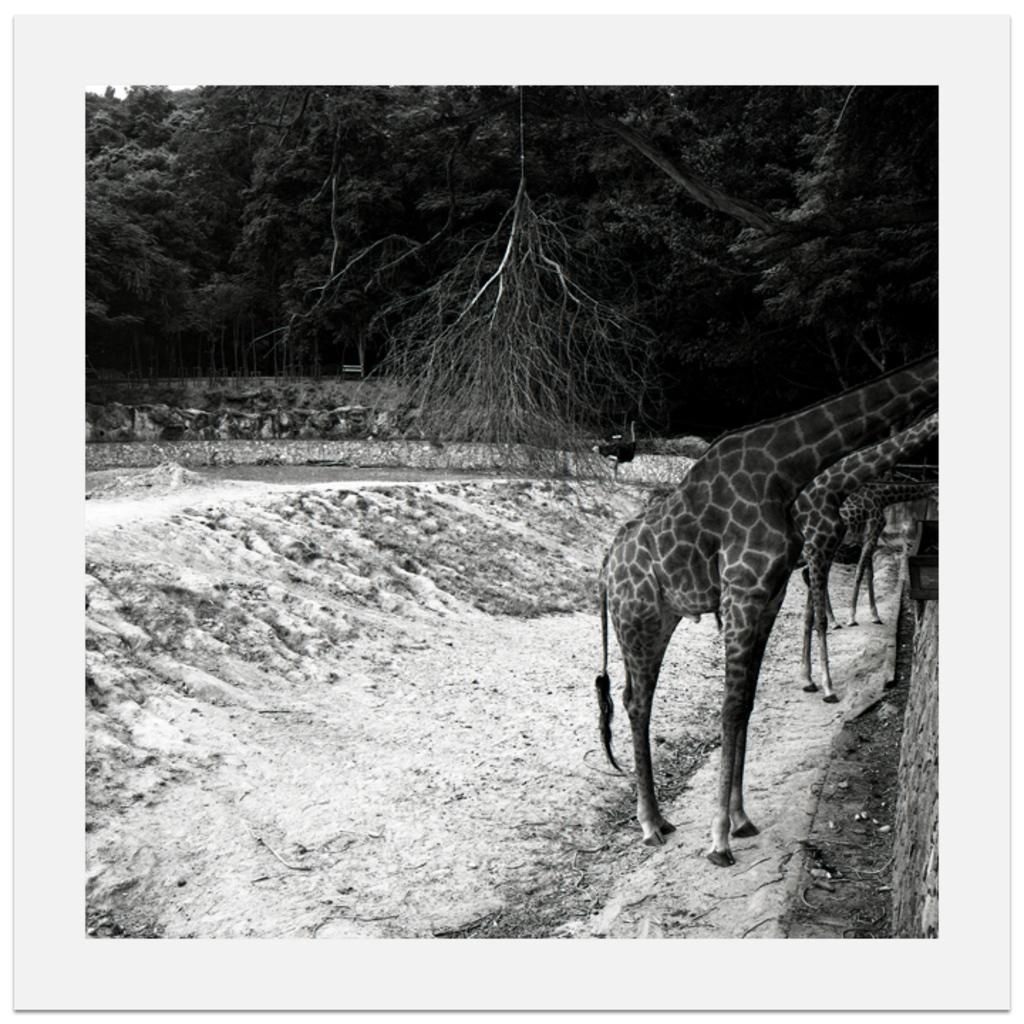What is the color scheme of the image? The image is black and white. What animals can be seen on the right side of the image? There are giraffes on the right side of the image. What type of vegetation is visible in the background of the image? There are trees visible in the background of the image. What type of honey can be seen dripping from the trees in the image? There is no honey present in the image; it is a black and white image featuring giraffes and trees. 